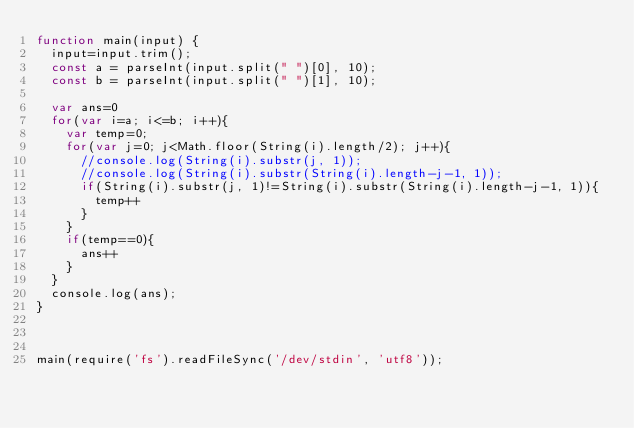Convert code to text. <code><loc_0><loc_0><loc_500><loc_500><_JavaScript_>function main(input) {
  input=input.trim();
  const a = parseInt(input.split(" ")[0], 10);
  const b = parseInt(input.split(" ")[1], 10);

  var ans=0
  for(var i=a; i<=b; i++){
    var temp=0;
    for(var j=0; j<Math.floor(String(i).length/2); j++){
      //console.log(String(i).substr(j, 1));
      //console.log(String(i).substr(String(i).length-j-1, 1));
      if(String(i).substr(j, 1)!=String(i).substr(String(i).length-j-1, 1)){
        temp++
      }
    }
    if(temp==0){
      ans++
    }
  }
  console.log(ans);
}



main(require('fs').readFileSync('/dev/stdin', 'utf8'));
</code> 